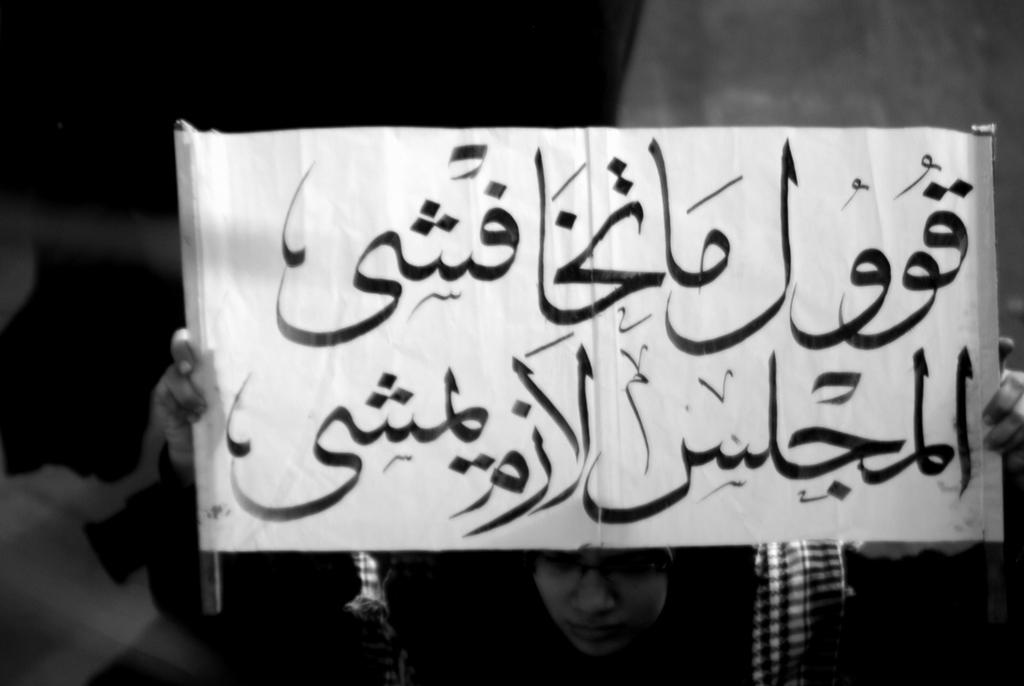What is the color scheme of the image? The image is black and white. What is the person in the image doing? The person is holding a banner with text in the image. Can you describe the background of the image? The background of the image is not clear. How many houses can be seen in the image? There are no houses visible in the image. Is there a donkey present in the image? There is no donkey present in the image. 